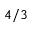Convert formula to latex. <formula><loc_0><loc_0><loc_500><loc_500>4 / 3</formula> 